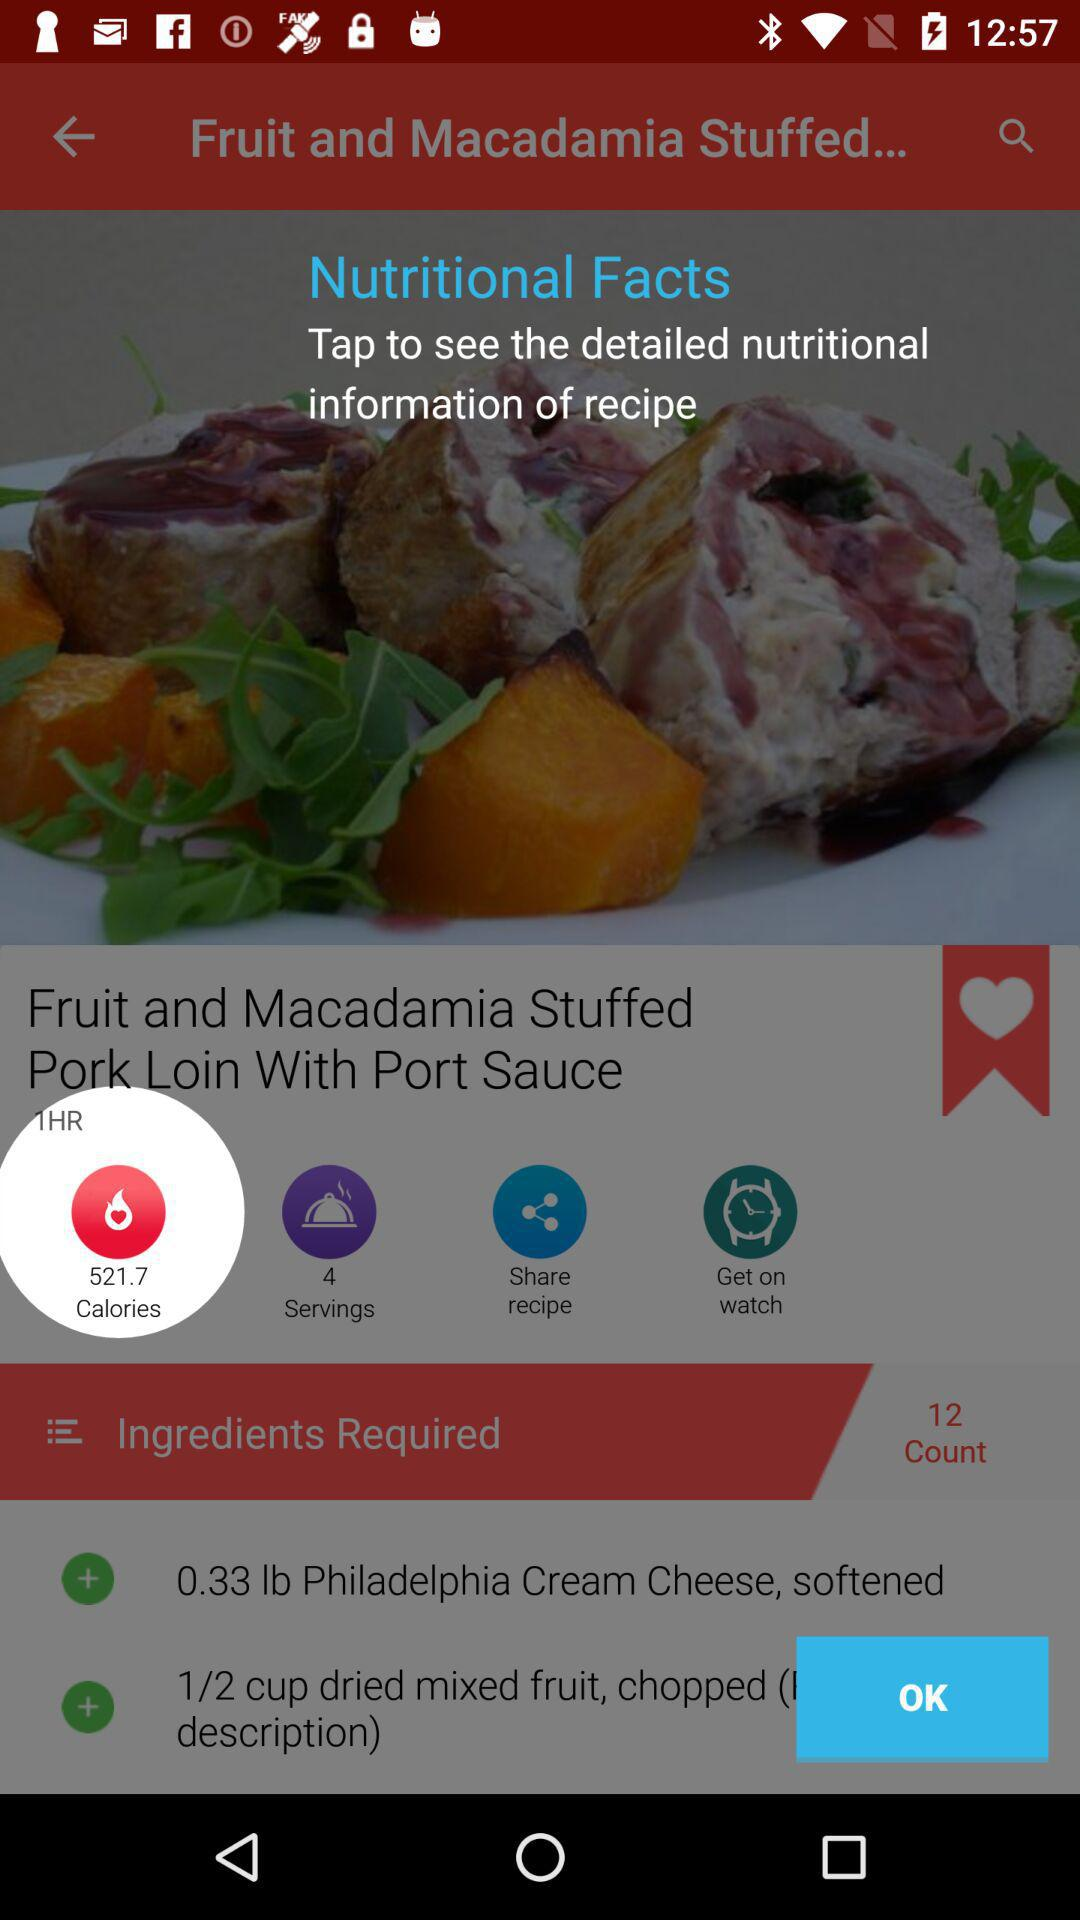How many servings does this recipe make?
Answer the question using a single word or phrase. 4 